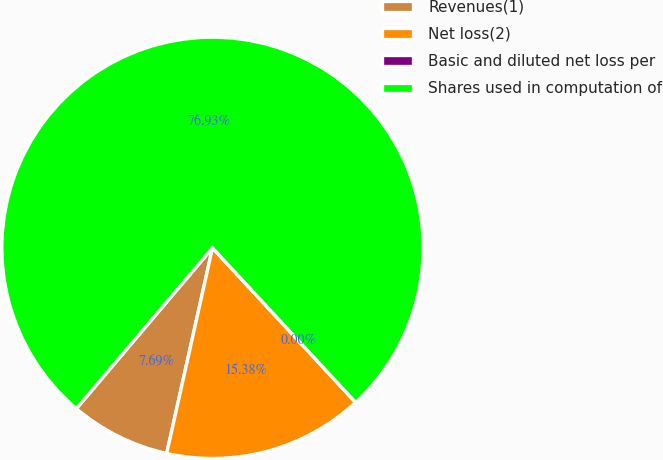Convert chart. <chart><loc_0><loc_0><loc_500><loc_500><pie_chart><fcel>Revenues(1)<fcel>Net loss(2)<fcel>Basic and diluted net loss per<fcel>Shares used in computation of<nl><fcel>7.69%<fcel>15.38%<fcel>0.0%<fcel>76.92%<nl></chart> 